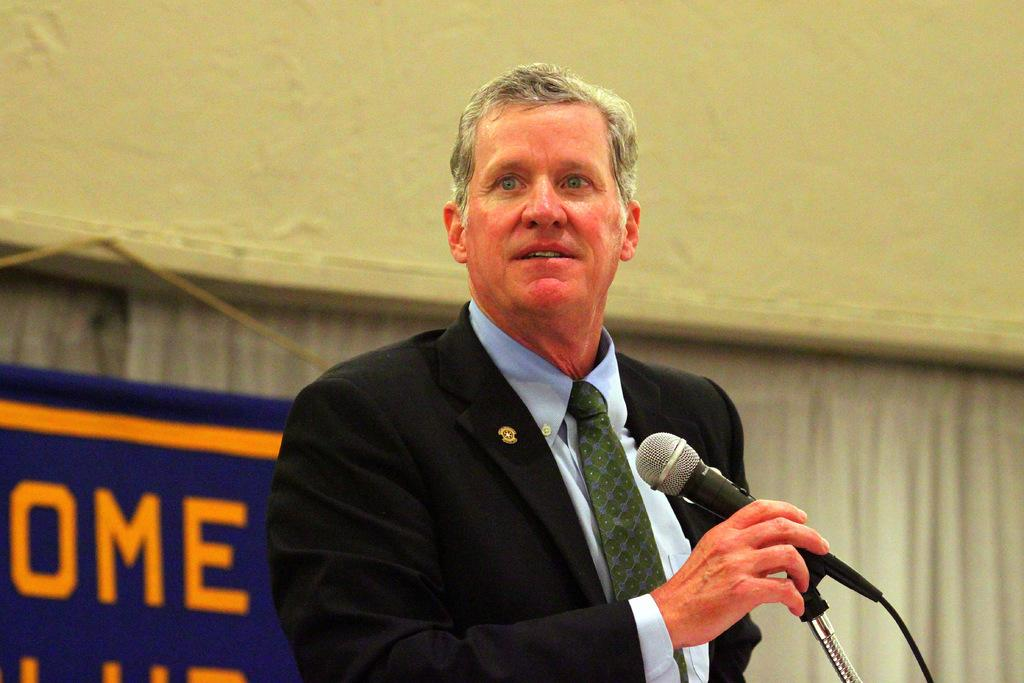What can be seen hanging in the image? There is a banner in the image. What is the man in the image holding? The man in the image is holding a microphone. What type of box is being used to measure the man's height in the image? There is no box or measurement of height in the image; it only features a banner and a man holding a microphone. 